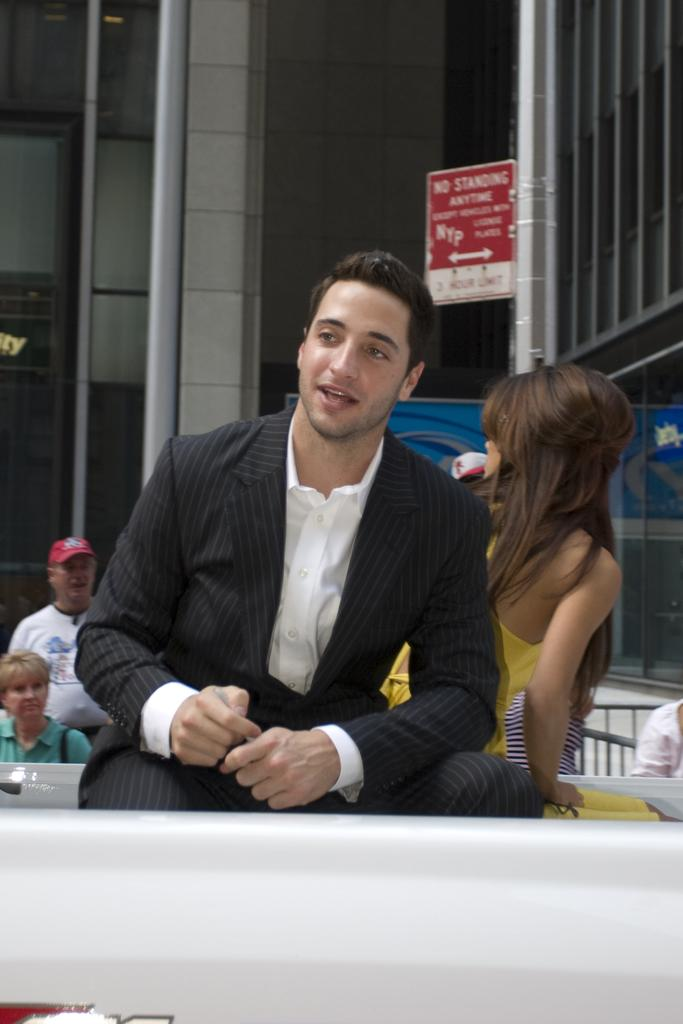How many people are in the image? There are people in the image, but the exact number is not specified. What is the position of one of the people in the image? One person is sitting. What is the sitting person wearing? The sitting person is wearing a black and white dress. What can be seen in the background of the image? There is a board, a glass building, and fencing visible in the background. What year is the oven being used in the image? There is no oven present in the image, so it is not possible to determine the year of its use. 